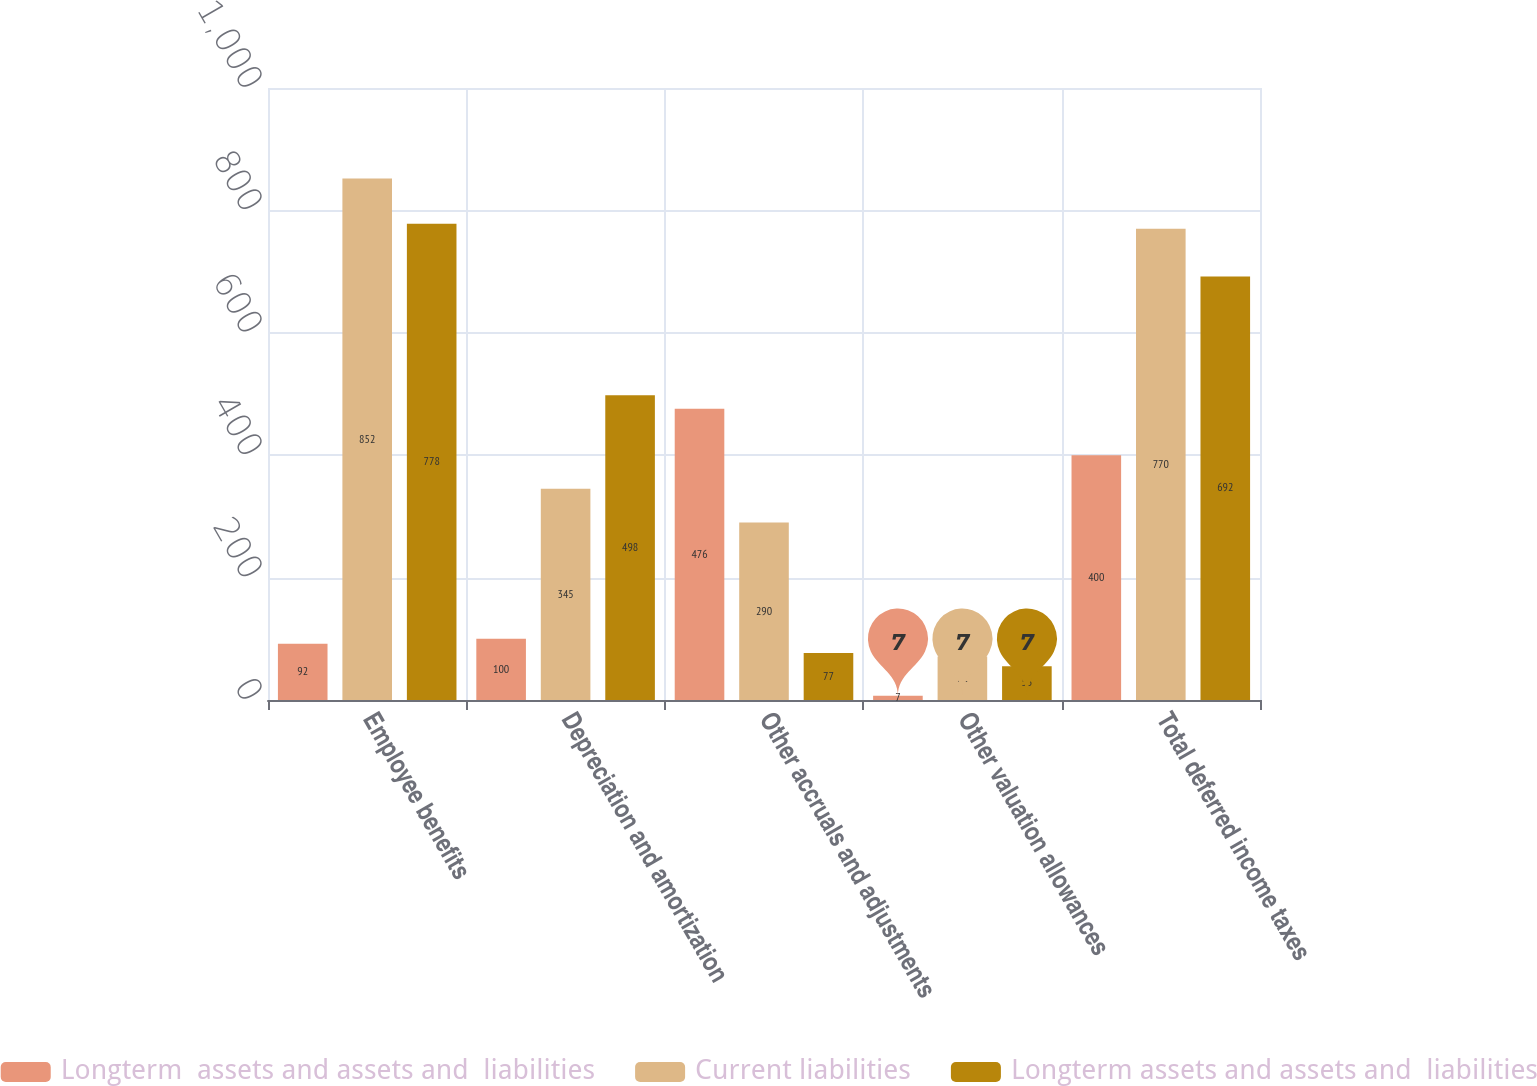<chart> <loc_0><loc_0><loc_500><loc_500><stacked_bar_chart><ecel><fcel>Employee benefits<fcel>Depreciation and amortization<fcel>Other accruals and adjustments<fcel>Other valuation allowances<fcel>Total deferred income taxes<nl><fcel>Longterm  assets and assets and  liabilities<fcel>92<fcel>100<fcel>476<fcel>7<fcel>400<nl><fcel>Current liabilities<fcel>852<fcel>345<fcel>290<fcel>71<fcel>770<nl><fcel>Longterm assets and assets and  liabilities<fcel>778<fcel>498<fcel>77<fcel>55<fcel>692<nl></chart> 